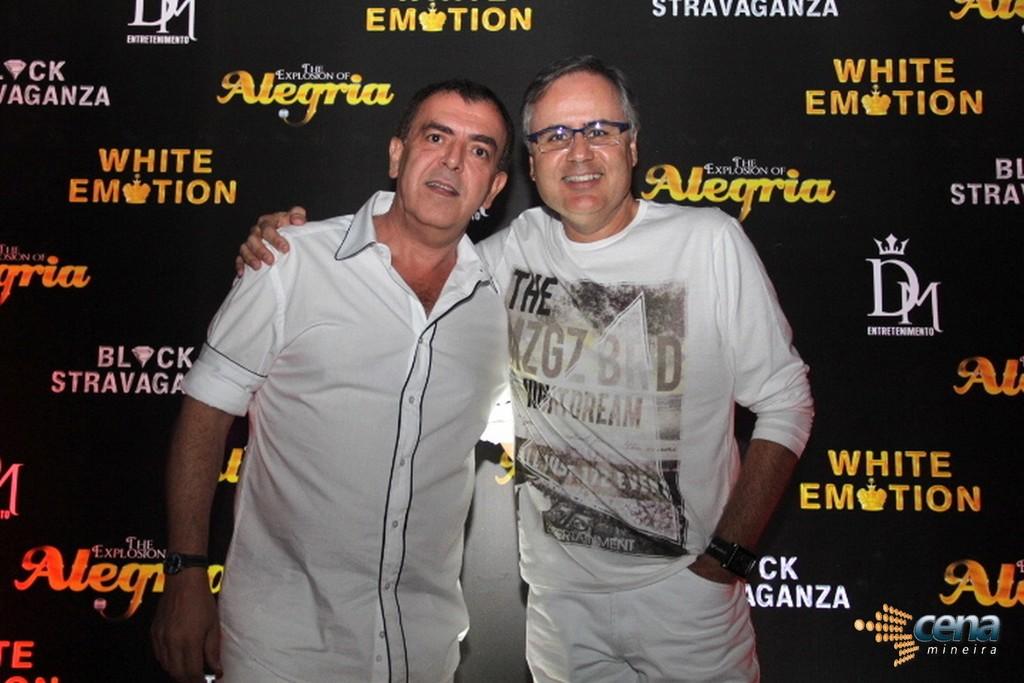What emotion color is referenced by the background text?
Provide a succinct answer. White. What is one of the sponsors?
Your answer should be very brief. White emotion. 